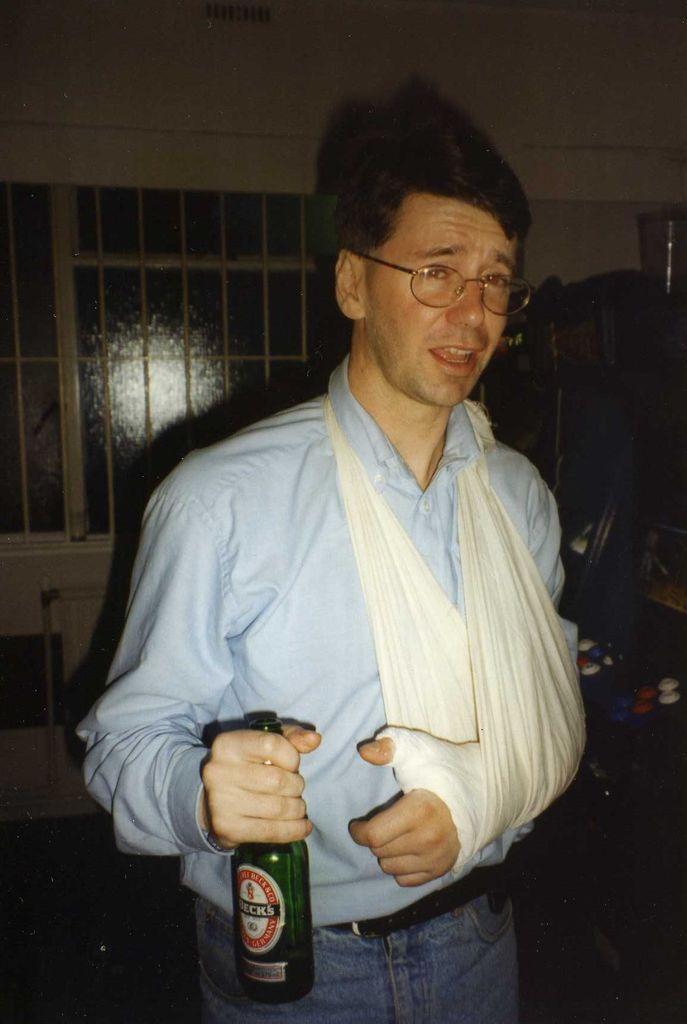Could you give a brief overview of what you see in this image? In this image I can see a man is standing and holding a bottle, I can also see he is wearing a specs. 